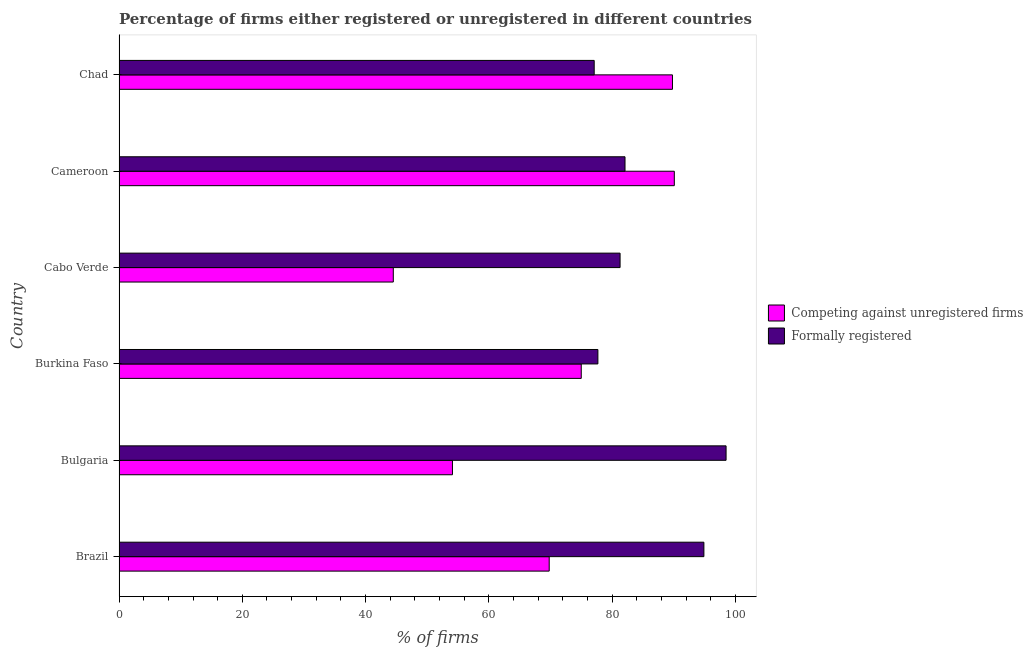How many groups of bars are there?
Provide a succinct answer. 6. Are the number of bars per tick equal to the number of legend labels?
Your answer should be very brief. Yes. How many bars are there on the 3rd tick from the top?
Make the answer very short. 2. What is the label of the 3rd group of bars from the top?
Give a very brief answer. Cabo Verde. In how many cases, is the number of bars for a given country not equal to the number of legend labels?
Make the answer very short. 0. What is the percentage of formally registered firms in Brazil?
Give a very brief answer. 94.9. Across all countries, what is the maximum percentage of registered firms?
Provide a succinct answer. 90.1. Across all countries, what is the minimum percentage of formally registered firms?
Ensure brevity in your answer.  77.1. In which country was the percentage of registered firms maximum?
Your answer should be compact. Cameroon. In which country was the percentage of formally registered firms minimum?
Your answer should be compact. Chad. What is the total percentage of formally registered firms in the graph?
Your answer should be very brief. 511.6. What is the difference between the percentage of formally registered firms in Brazil and that in Cabo Verde?
Give a very brief answer. 13.6. What is the difference between the percentage of formally registered firms in Chad and the percentage of registered firms in Cabo Verde?
Offer a very short reply. 32.6. What is the average percentage of registered firms per country?
Offer a terse response. 70.55. What is the ratio of the percentage of formally registered firms in Cabo Verde to that in Cameroon?
Your answer should be compact. 0.99. Is the percentage of registered firms in Brazil less than that in Bulgaria?
Your answer should be compact. No. Is the difference between the percentage of registered firms in Burkina Faso and Chad greater than the difference between the percentage of formally registered firms in Burkina Faso and Chad?
Your response must be concise. No. What is the difference between the highest and the second highest percentage of registered firms?
Provide a succinct answer. 0.3. What is the difference between the highest and the lowest percentage of registered firms?
Your answer should be compact. 45.6. Is the sum of the percentage of formally registered firms in Bulgaria and Cabo Verde greater than the maximum percentage of registered firms across all countries?
Provide a short and direct response. Yes. What does the 2nd bar from the top in Chad represents?
Your response must be concise. Competing against unregistered firms. What does the 2nd bar from the bottom in Chad represents?
Offer a very short reply. Formally registered. Are the values on the major ticks of X-axis written in scientific E-notation?
Offer a very short reply. No. Where does the legend appear in the graph?
Provide a succinct answer. Center right. What is the title of the graph?
Provide a succinct answer. Percentage of firms either registered or unregistered in different countries. Does "External balance on goods" appear as one of the legend labels in the graph?
Provide a short and direct response. No. What is the label or title of the X-axis?
Provide a short and direct response. % of firms. What is the % of firms in Competing against unregistered firms in Brazil?
Ensure brevity in your answer.  69.8. What is the % of firms of Formally registered in Brazil?
Make the answer very short. 94.9. What is the % of firms of Competing against unregistered firms in Bulgaria?
Your answer should be compact. 54.1. What is the % of firms in Formally registered in Bulgaria?
Ensure brevity in your answer.  98.5. What is the % of firms in Formally registered in Burkina Faso?
Your answer should be very brief. 77.7. What is the % of firms of Competing against unregistered firms in Cabo Verde?
Keep it short and to the point. 44.5. What is the % of firms in Formally registered in Cabo Verde?
Your answer should be compact. 81.3. What is the % of firms in Competing against unregistered firms in Cameroon?
Offer a very short reply. 90.1. What is the % of firms in Formally registered in Cameroon?
Offer a terse response. 82.1. What is the % of firms of Competing against unregistered firms in Chad?
Your answer should be very brief. 89.8. What is the % of firms of Formally registered in Chad?
Offer a terse response. 77.1. Across all countries, what is the maximum % of firms of Competing against unregistered firms?
Your answer should be compact. 90.1. Across all countries, what is the maximum % of firms in Formally registered?
Offer a very short reply. 98.5. Across all countries, what is the minimum % of firms in Competing against unregistered firms?
Your answer should be very brief. 44.5. Across all countries, what is the minimum % of firms of Formally registered?
Offer a terse response. 77.1. What is the total % of firms of Competing against unregistered firms in the graph?
Your answer should be compact. 423.3. What is the total % of firms of Formally registered in the graph?
Your answer should be compact. 511.6. What is the difference between the % of firms in Formally registered in Brazil and that in Bulgaria?
Offer a terse response. -3.6. What is the difference between the % of firms of Formally registered in Brazil and that in Burkina Faso?
Provide a short and direct response. 17.2. What is the difference between the % of firms of Competing against unregistered firms in Brazil and that in Cabo Verde?
Provide a short and direct response. 25.3. What is the difference between the % of firms in Formally registered in Brazil and that in Cabo Verde?
Provide a short and direct response. 13.6. What is the difference between the % of firms in Competing against unregistered firms in Brazil and that in Cameroon?
Ensure brevity in your answer.  -20.3. What is the difference between the % of firms of Formally registered in Brazil and that in Cameroon?
Your answer should be compact. 12.8. What is the difference between the % of firms of Competing against unregistered firms in Brazil and that in Chad?
Keep it short and to the point. -20. What is the difference between the % of firms of Formally registered in Brazil and that in Chad?
Offer a terse response. 17.8. What is the difference between the % of firms of Competing against unregistered firms in Bulgaria and that in Burkina Faso?
Your answer should be very brief. -20.9. What is the difference between the % of firms of Formally registered in Bulgaria and that in Burkina Faso?
Make the answer very short. 20.8. What is the difference between the % of firms of Competing against unregistered firms in Bulgaria and that in Cabo Verde?
Your answer should be compact. 9.6. What is the difference between the % of firms in Competing against unregistered firms in Bulgaria and that in Cameroon?
Give a very brief answer. -36. What is the difference between the % of firms of Competing against unregistered firms in Bulgaria and that in Chad?
Ensure brevity in your answer.  -35.7. What is the difference between the % of firms in Formally registered in Bulgaria and that in Chad?
Give a very brief answer. 21.4. What is the difference between the % of firms of Competing against unregistered firms in Burkina Faso and that in Cabo Verde?
Give a very brief answer. 30.5. What is the difference between the % of firms in Formally registered in Burkina Faso and that in Cabo Verde?
Keep it short and to the point. -3.6. What is the difference between the % of firms in Competing against unregistered firms in Burkina Faso and that in Cameroon?
Offer a very short reply. -15.1. What is the difference between the % of firms in Competing against unregistered firms in Burkina Faso and that in Chad?
Provide a succinct answer. -14.8. What is the difference between the % of firms in Competing against unregistered firms in Cabo Verde and that in Cameroon?
Your answer should be very brief. -45.6. What is the difference between the % of firms in Competing against unregistered firms in Cabo Verde and that in Chad?
Offer a terse response. -45.3. What is the difference between the % of firms in Competing against unregistered firms in Brazil and the % of firms in Formally registered in Bulgaria?
Provide a short and direct response. -28.7. What is the difference between the % of firms of Competing against unregistered firms in Bulgaria and the % of firms of Formally registered in Burkina Faso?
Offer a very short reply. -23.6. What is the difference between the % of firms of Competing against unregistered firms in Bulgaria and the % of firms of Formally registered in Cabo Verde?
Provide a short and direct response. -27.2. What is the difference between the % of firms of Competing against unregistered firms in Bulgaria and the % of firms of Formally registered in Chad?
Give a very brief answer. -23. What is the difference between the % of firms in Competing against unregistered firms in Burkina Faso and the % of firms in Formally registered in Cameroon?
Make the answer very short. -7.1. What is the difference between the % of firms in Competing against unregistered firms in Burkina Faso and the % of firms in Formally registered in Chad?
Your answer should be compact. -2.1. What is the difference between the % of firms in Competing against unregistered firms in Cabo Verde and the % of firms in Formally registered in Cameroon?
Provide a short and direct response. -37.6. What is the difference between the % of firms of Competing against unregistered firms in Cabo Verde and the % of firms of Formally registered in Chad?
Your response must be concise. -32.6. What is the average % of firms of Competing against unregistered firms per country?
Ensure brevity in your answer.  70.55. What is the average % of firms of Formally registered per country?
Provide a succinct answer. 85.27. What is the difference between the % of firms of Competing against unregistered firms and % of firms of Formally registered in Brazil?
Provide a short and direct response. -25.1. What is the difference between the % of firms in Competing against unregistered firms and % of firms in Formally registered in Bulgaria?
Ensure brevity in your answer.  -44.4. What is the difference between the % of firms of Competing against unregistered firms and % of firms of Formally registered in Cabo Verde?
Keep it short and to the point. -36.8. What is the difference between the % of firms of Competing against unregistered firms and % of firms of Formally registered in Cameroon?
Your answer should be very brief. 8. What is the ratio of the % of firms in Competing against unregistered firms in Brazil to that in Bulgaria?
Your answer should be compact. 1.29. What is the ratio of the % of firms in Formally registered in Brazil to that in Bulgaria?
Offer a terse response. 0.96. What is the ratio of the % of firms of Competing against unregistered firms in Brazil to that in Burkina Faso?
Provide a short and direct response. 0.93. What is the ratio of the % of firms in Formally registered in Brazil to that in Burkina Faso?
Ensure brevity in your answer.  1.22. What is the ratio of the % of firms of Competing against unregistered firms in Brazil to that in Cabo Verde?
Offer a terse response. 1.57. What is the ratio of the % of firms in Formally registered in Brazil to that in Cabo Verde?
Offer a very short reply. 1.17. What is the ratio of the % of firms of Competing against unregistered firms in Brazil to that in Cameroon?
Give a very brief answer. 0.77. What is the ratio of the % of firms in Formally registered in Brazil to that in Cameroon?
Your answer should be very brief. 1.16. What is the ratio of the % of firms of Competing against unregistered firms in Brazil to that in Chad?
Your response must be concise. 0.78. What is the ratio of the % of firms in Formally registered in Brazil to that in Chad?
Give a very brief answer. 1.23. What is the ratio of the % of firms in Competing against unregistered firms in Bulgaria to that in Burkina Faso?
Your response must be concise. 0.72. What is the ratio of the % of firms in Formally registered in Bulgaria to that in Burkina Faso?
Your response must be concise. 1.27. What is the ratio of the % of firms in Competing against unregistered firms in Bulgaria to that in Cabo Verde?
Offer a terse response. 1.22. What is the ratio of the % of firms of Formally registered in Bulgaria to that in Cabo Verde?
Make the answer very short. 1.21. What is the ratio of the % of firms of Competing against unregistered firms in Bulgaria to that in Cameroon?
Ensure brevity in your answer.  0.6. What is the ratio of the % of firms in Formally registered in Bulgaria to that in Cameroon?
Your answer should be compact. 1.2. What is the ratio of the % of firms in Competing against unregistered firms in Bulgaria to that in Chad?
Provide a short and direct response. 0.6. What is the ratio of the % of firms in Formally registered in Bulgaria to that in Chad?
Make the answer very short. 1.28. What is the ratio of the % of firms in Competing against unregistered firms in Burkina Faso to that in Cabo Verde?
Your response must be concise. 1.69. What is the ratio of the % of firms in Formally registered in Burkina Faso to that in Cabo Verde?
Make the answer very short. 0.96. What is the ratio of the % of firms of Competing against unregistered firms in Burkina Faso to that in Cameroon?
Your answer should be compact. 0.83. What is the ratio of the % of firms in Formally registered in Burkina Faso to that in Cameroon?
Your answer should be compact. 0.95. What is the ratio of the % of firms of Competing against unregistered firms in Burkina Faso to that in Chad?
Offer a terse response. 0.84. What is the ratio of the % of firms of Competing against unregistered firms in Cabo Verde to that in Cameroon?
Provide a succinct answer. 0.49. What is the ratio of the % of firms in Formally registered in Cabo Verde to that in Cameroon?
Your answer should be very brief. 0.99. What is the ratio of the % of firms of Competing against unregistered firms in Cabo Verde to that in Chad?
Make the answer very short. 0.5. What is the ratio of the % of firms of Formally registered in Cabo Verde to that in Chad?
Give a very brief answer. 1.05. What is the ratio of the % of firms in Formally registered in Cameroon to that in Chad?
Make the answer very short. 1.06. What is the difference between the highest and the lowest % of firms of Competing against unregistered firms?
Offer a terse response. 45.6. What is the difference between the highest and the lowest % of firms in Formally registered?
Your response must be concise. 21.4. 